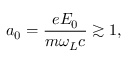Convert formula to latex. <formula><loc_0><loc_0><loc_500><loc_500>a _ { 0 } = \frac { e E _ { 0 } } { m \omega _ { L } c } \gtrsim 1 ,</formula> 